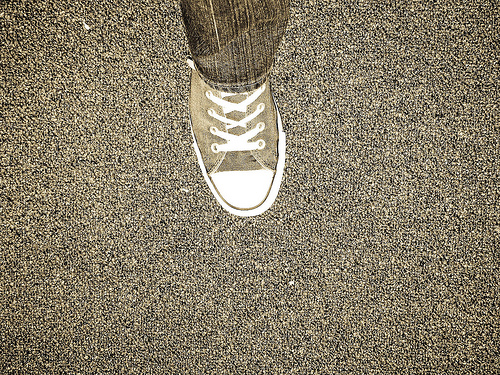<image>
Can you confirm if the shoes is in front of the pants? Yes. The shoes is positioned in front of the pants, appearing closer to the camera viewpoint. 